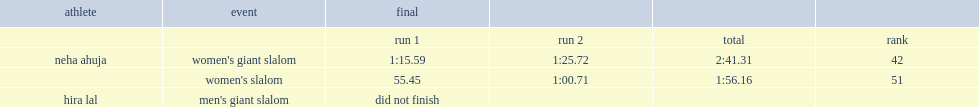What was the result that neha ahuja got in the women's slalom in first run? 55.45. Could you help me parse every detail presented in this table? {'header': ['athlete', 'event', 'final', '', '', ''], 'rows': [['', '', 'run 1', 'run 2', 'total', 'rank'], ['neha ahuja', "women's giant slalom", '1:15.59', '1:25.72', '2:41.31', '42'], ['', "women's slalom", '55.45', '1:00.71', '1:56.16', '51'], ['hira lal', "men's giant slalom", 'did not finish', '', '', '']]} 